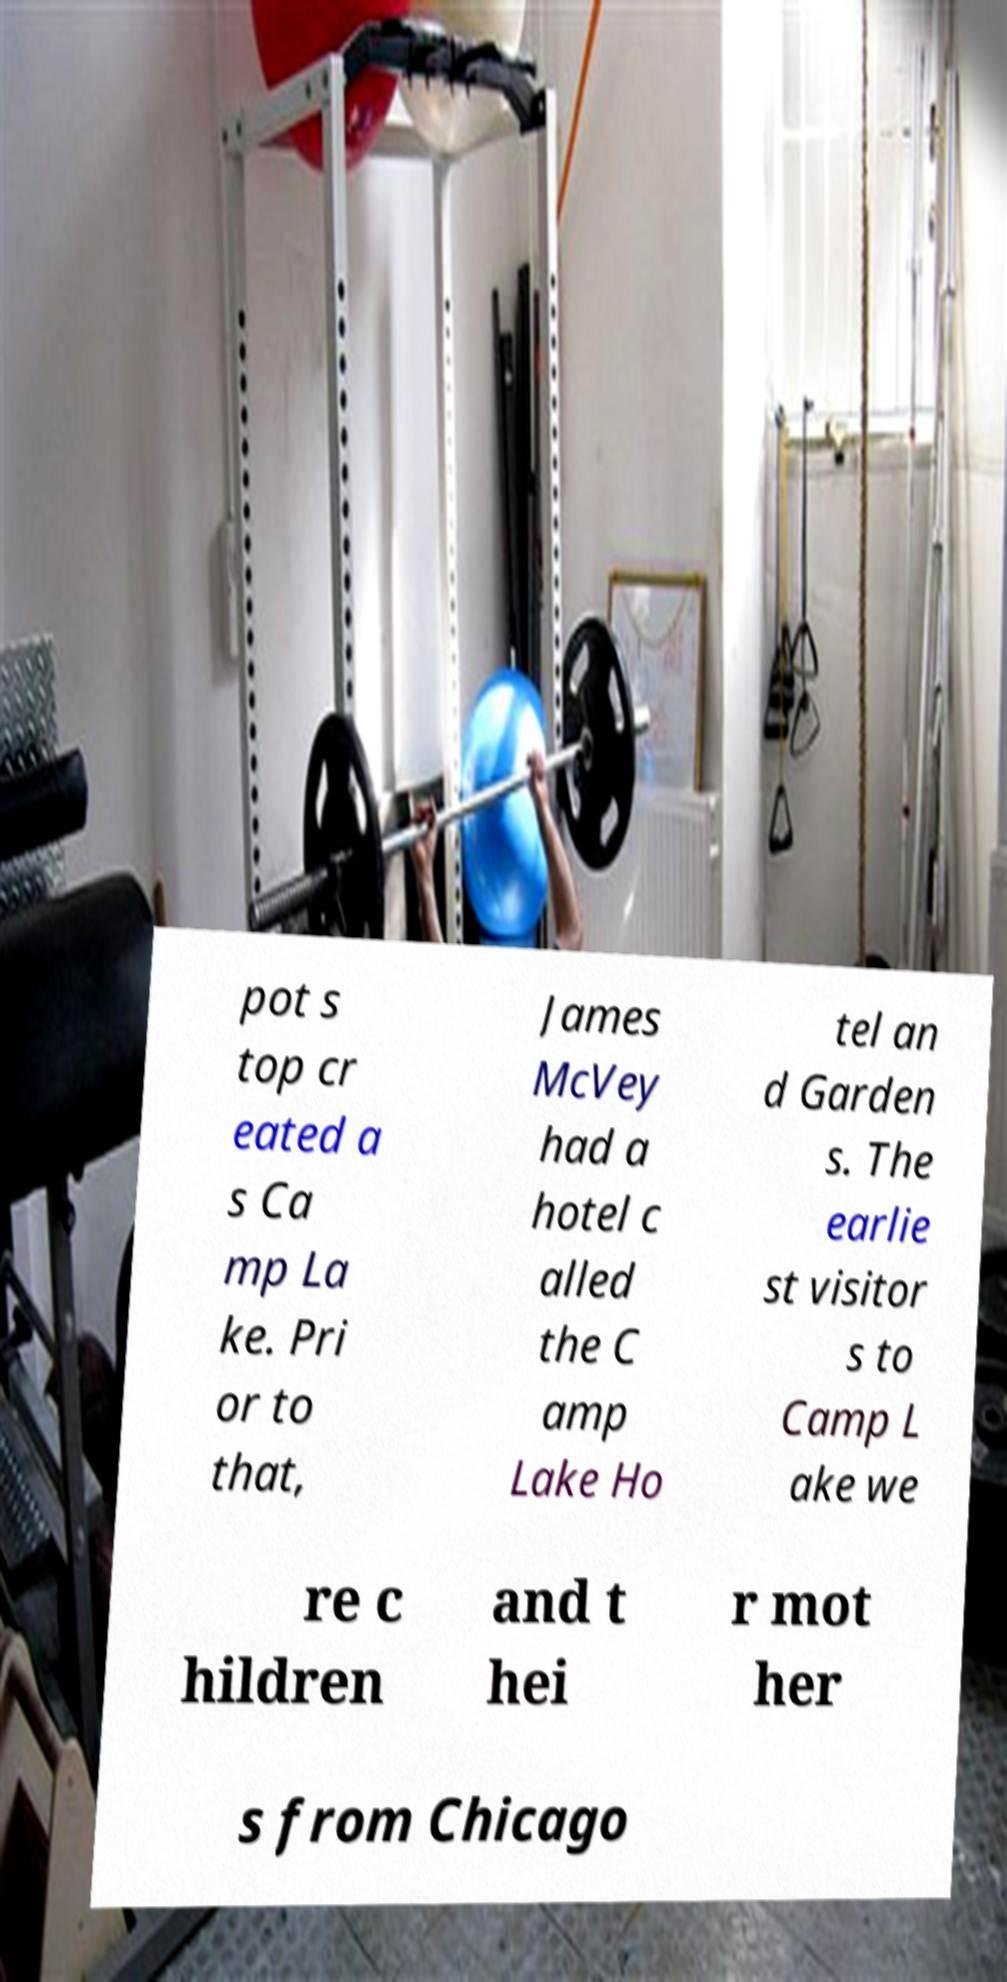I need the written content from this picture converted into text. Can you do that? pot s top cr eated a s Ca mp La ke. Pri or to that, James McVey had a hotel c alled the C amp Lake Ho tel an d Garden s. The earlie st visitor s to Camp L ake we re c hildren and t hei r mot her s from Chicago 